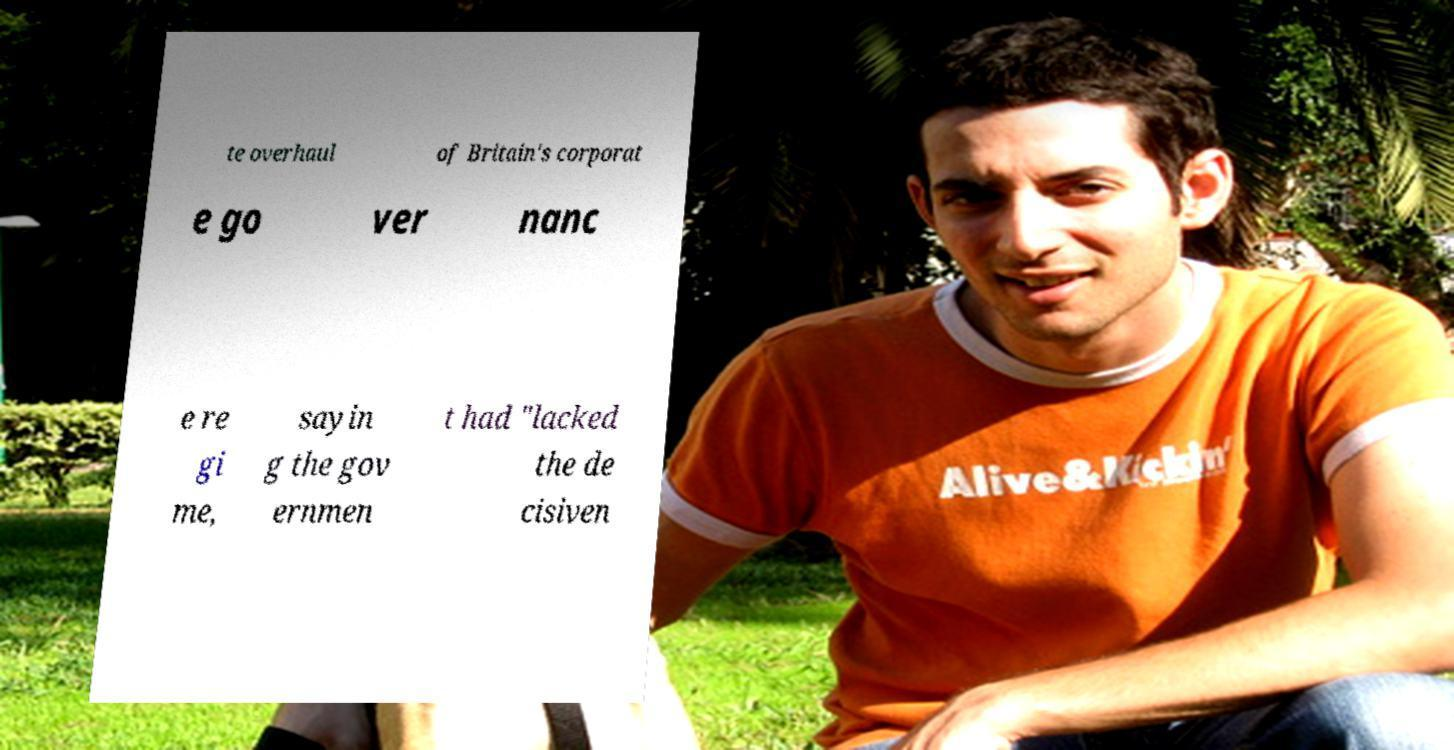There's text embedded in this image that I need extracted. Can you transcribe it verbatim? te overhaul of Britain's corporat e go ver nanc e re gi me, sayin g the gov ernmen t had "lacked the de cisiven 